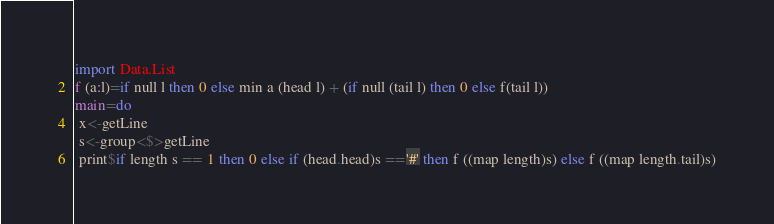Convert code to text. <code><loc_0><loc_0><loc_500><loc_500><_Haskell_>import Data.List
f (a:l)=if null l then 0 else min a (head l) + (if null (tail l) then 0 else f(tail l))
main=do
 x<-getLine
 s<-group<$>getLine
 print$if length s == 1 then 0 else if (head.head)s =='#' then f ((map length)s) else f ((map length.tail)s)</code> 